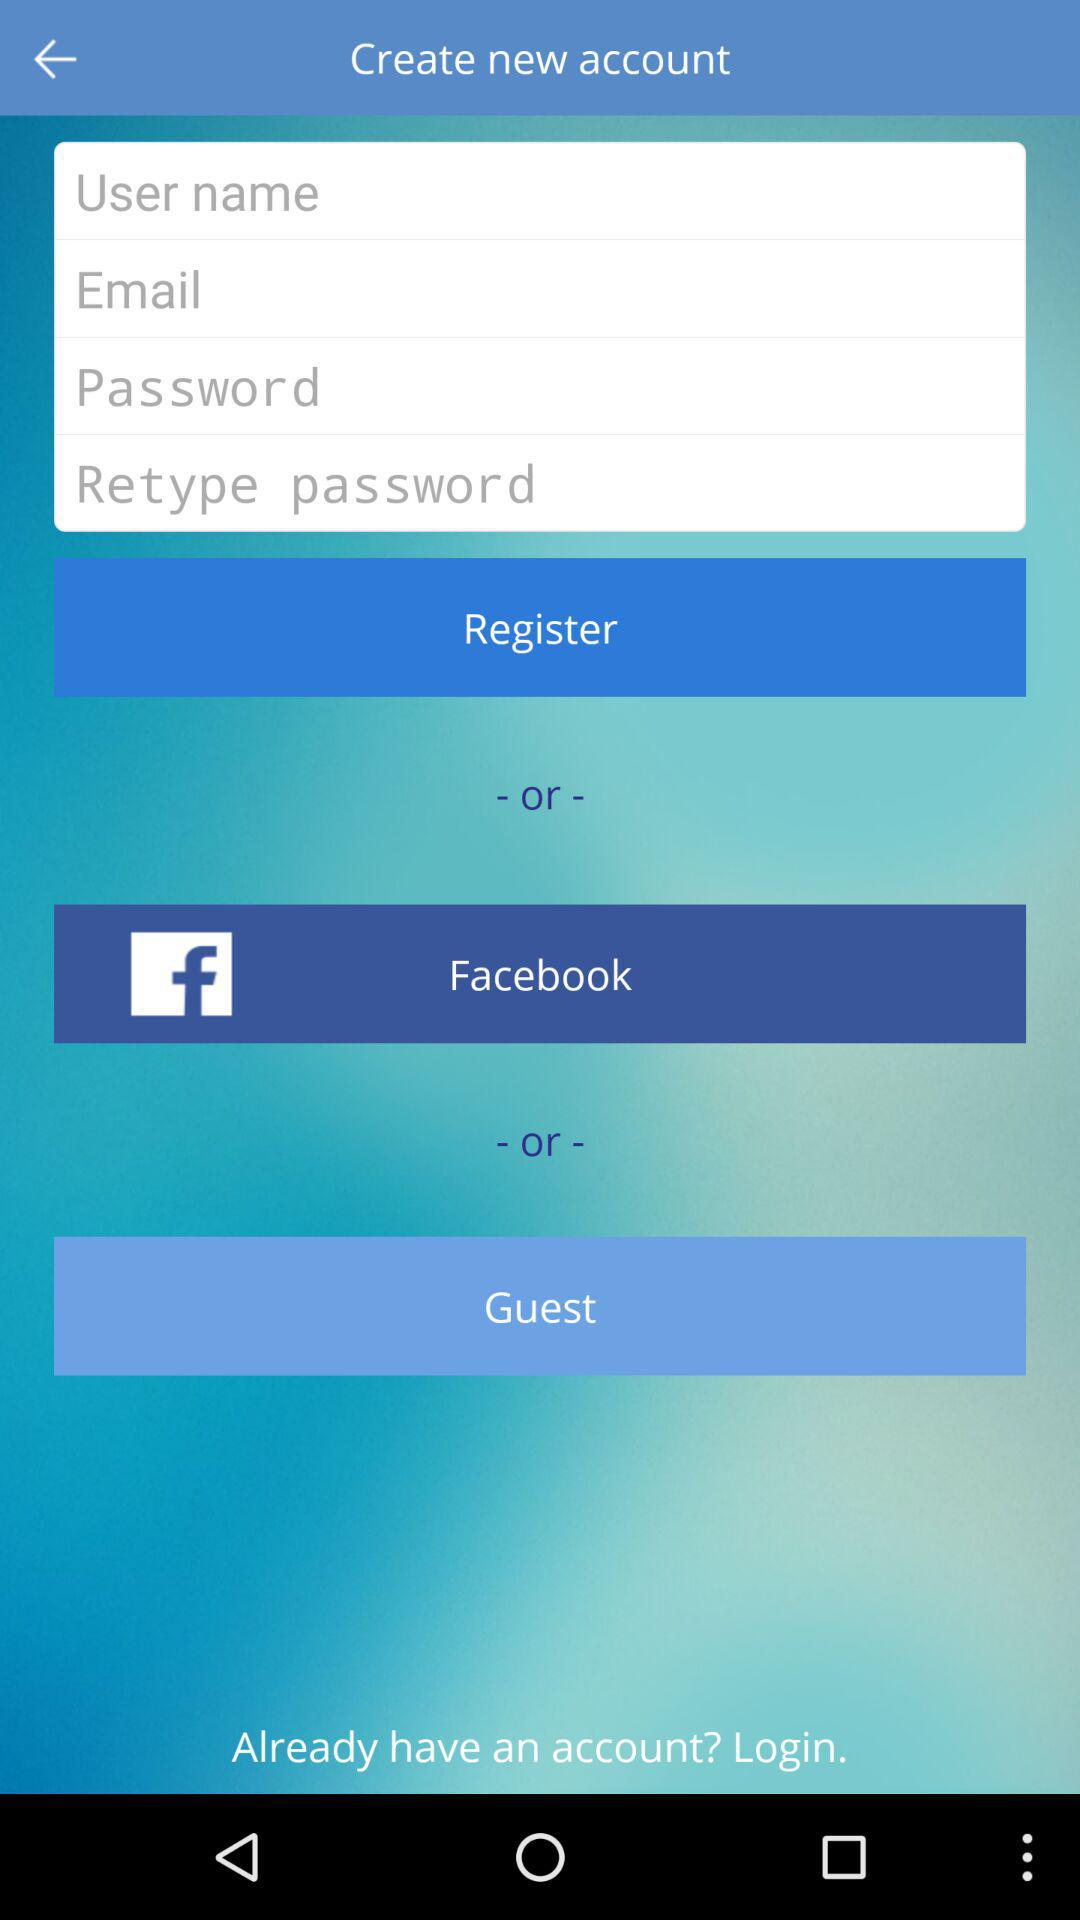What is the entered email address?
When the provided information is insufficient, respond with <no answer>. <no answer> 